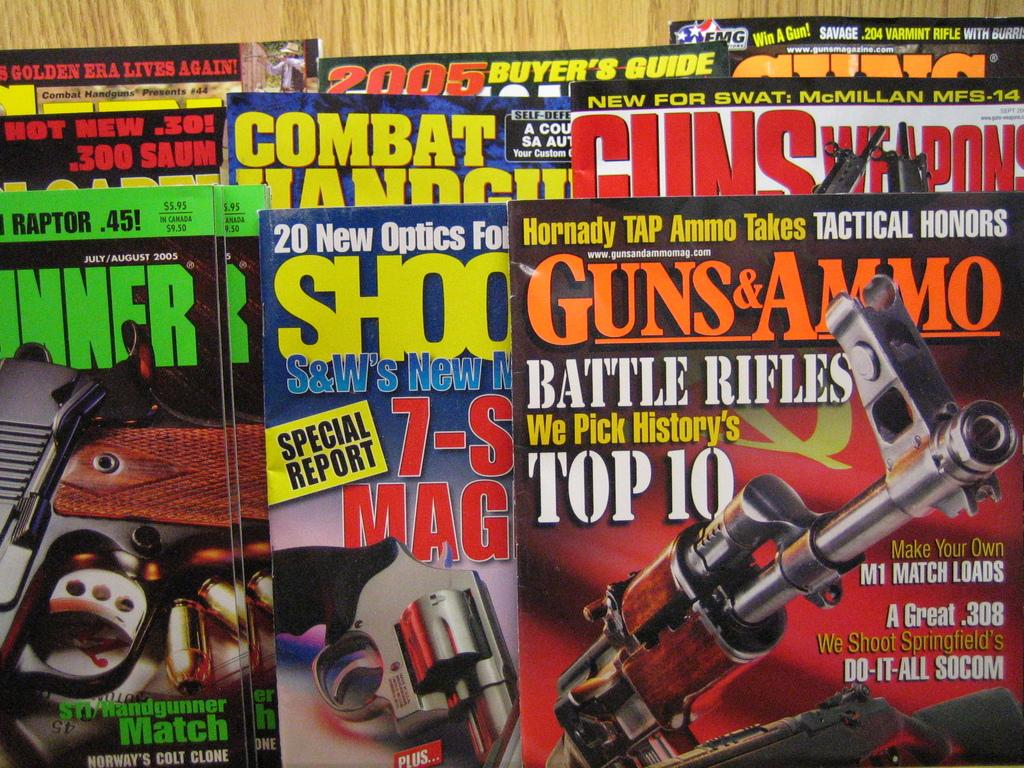<image>
Relay a brief, clear account of the picture shown. Several magazines shown including one called Guns &Ammo. 